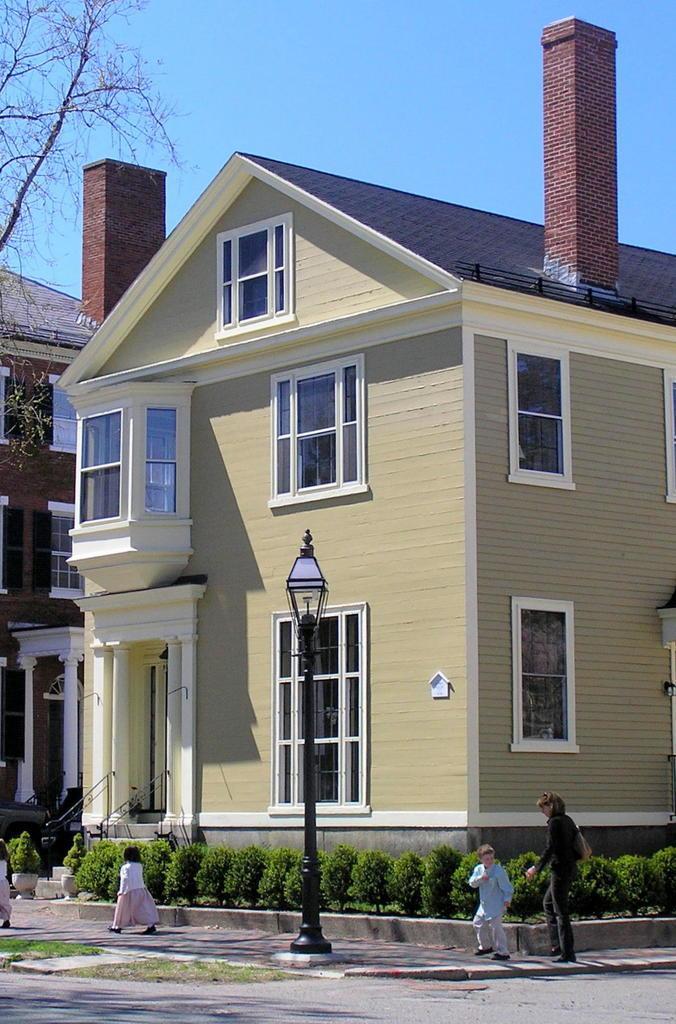Describe this image in one or two sentences. In this image we can see a pole, plants, grass, windows, branches, buildings, and few people. In the background there is sky. 